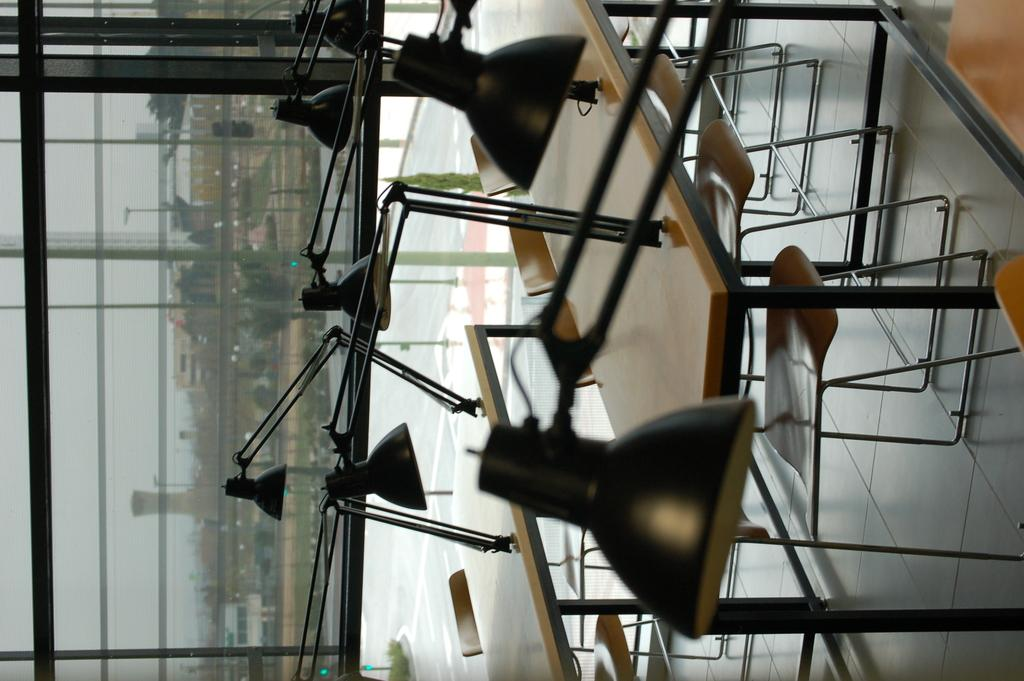What type of furniture is present in the image? There is a study table in the image. What is placed on the study table? There is a lamp on the study table. What type of seating is on the floor? There are chairs on the floor. What feature allows natural light into the room? There is a glass window in the image. What can be seen in the distance from the window? There are buildings visible in the background of the image. What type of yarn is being used by the judge in the image? There is no judge or yarn present in the image. What type of pail is visible in the image? There is no pail visible in the image. 